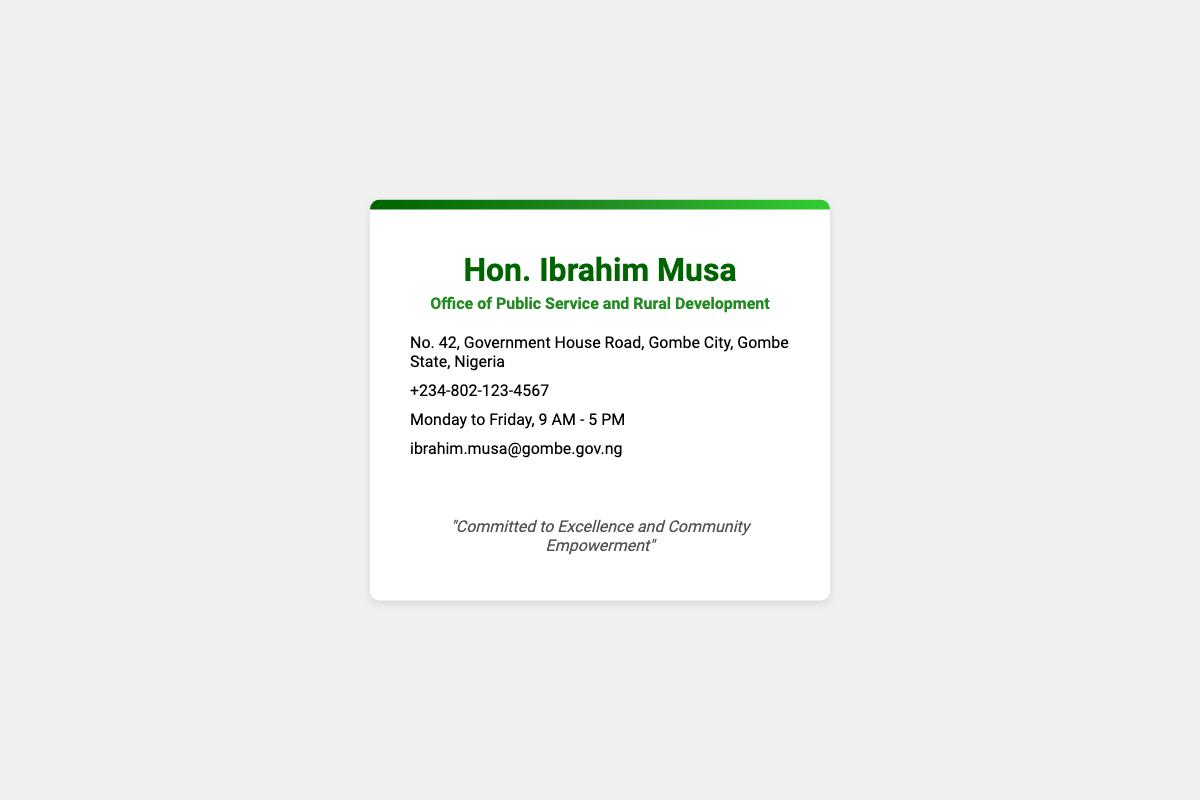What is the name of the official? The document prominently displays the name "Hon. Ibrahim Musa" at the top.
Answer: Hon. Ibrahim Musa What is the office title? The title "Office of Public Service and Rural Development" appears below the name.
Answer: Office of Public Service and Rural Development What is the office address? The address provided is listed under the location section of the card.
Answer: No. 42, Government House Road, Gombe City, Gombe State, Nigeria What is the phone number? The contact number is located in the info section of the card.
Answer: +234-802-123-4567 What are the working hours? The working hours are specified as "Monday to Friday, 9 AM - 5 PM".
Answer: Monday to Friday, 9 AM - 5 PM What is the email address for inquiries? The email is mentioned in the contact information section.
Answer: ibrahim.musa@gombe.gov.ng What social media platforms are linked? The card features links to Twitter and Facebook for public engagement.
Answer: Twitter and Facebook What is the motto displayed on the card? The motto is shown at the bottom of the card, highlighting the official's commitment.
Answer: "Committed to Excellence and Community Empowerment" What is the color theme used in the card? The colors used in gradients and text primarily consist of various shades of green.
Answer: Green 